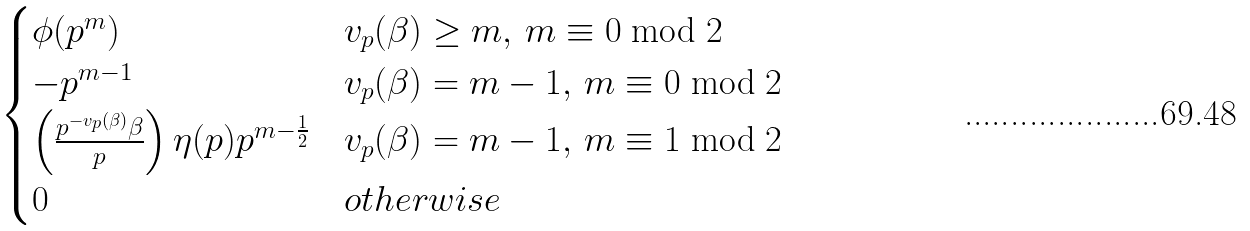Convert formula to latex. <formula><loc_0><loc_0><loc_500><loc_500>\begin{cases} \phi ( p ^ { m } ) & v _ { p } ( \beta ) \geq m , \, m \equiv 0 \bmod 2 \\ - p ^ { m - 1 } & v _ { p } ( \beta ) = m - 1 , \, m \equiv 0 \bmod 2 \\ \left ( \frac { p ^ { - v _ { p } ( \beta ) } \beta } { p } \right ) \eta ( p ) p ^ { m - \frac { 1 } { 2 } } & v _ { p } ( \beta ) = m - 1 , \, m \equiv 1 \bmod 2 \\ 0 & o t h e r w i s e \end{cases}</formula> 